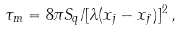Convert formula to latex. <formula><loc_0><loc_0><loc_500><loc_500>\tau _ { m } = 8 \pi S _ { q } / [ \lambda ( x _ { j } - x _ { j ^ { \prime } } ) ] ^ { 2 } \, ,</formula> 